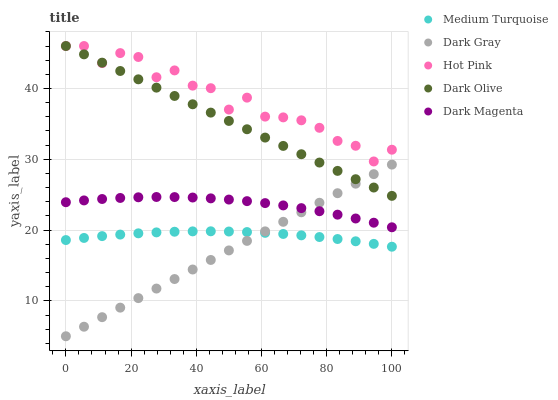Does Dark Gray have the minimum area under the curve?
Answer yes or no. Yes. Does Hot Pink have the maximum area under the curve?
Answer yes or no. Yes. Does Dark Olive have the minimum area under the curve?
Answer yes or no. No. Does Dark Olive have the maximum area under the curve?
Answer yes or no. No. Is Dark Gray the smoothest?
Answer yes or no. Yes. Is Hot Pink the roughest?
Answer yes or no. Yes. Is Dark Olive the smoothest?
Answer yes or no. No. Is Dark Olive the roughest?
Answer yes or no. No. Does Dark Gray have the lowest value?
Answer yes or no. Yes. Does Dark Olive have the lowest value?
Answer yes or no. No. Does Dark Olive have the highest value?
Answer yes or no. Yes. Does Dark Magenta have the highest value?
Answer yes or no. No. Is Dark Magenta less than Hot Pink?
Answer yes or no. Yes. Is Dark Magenta greater than Medium Turquoise?
Answer yes or no. Yes. Does Dark Magenta intersect Dark Gray?
Answer yes or no. Yes. Is Dark Magenta less than Dark Gray?
Answer yes or no. No. Is Dark Magenta greater than Dark Gray?
Answer yes or no. No. Does Dark Magenta intersect Hot Pink?
Answer yes or no. No. 